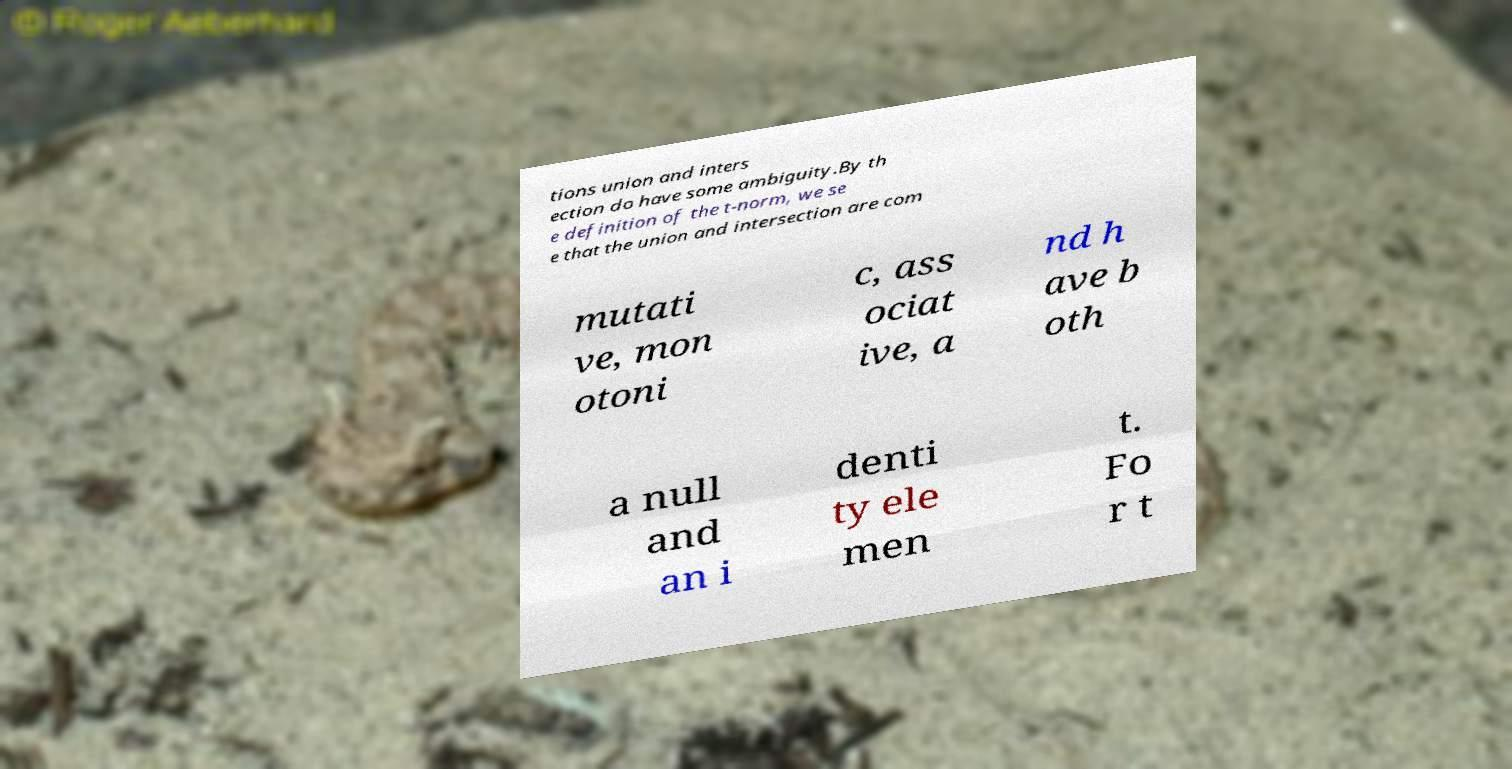For documentation purposes, I need the text within this image transcribed. Could you provide that? tions union and inters ection do have some ambiguity.By th e definition of the t-norm, we se e that the union and intersection are com mutati ve, mon otoni c, ass ociat ive, a nd h ave b oth a null and an i denti ty ele men t. Fo r t 